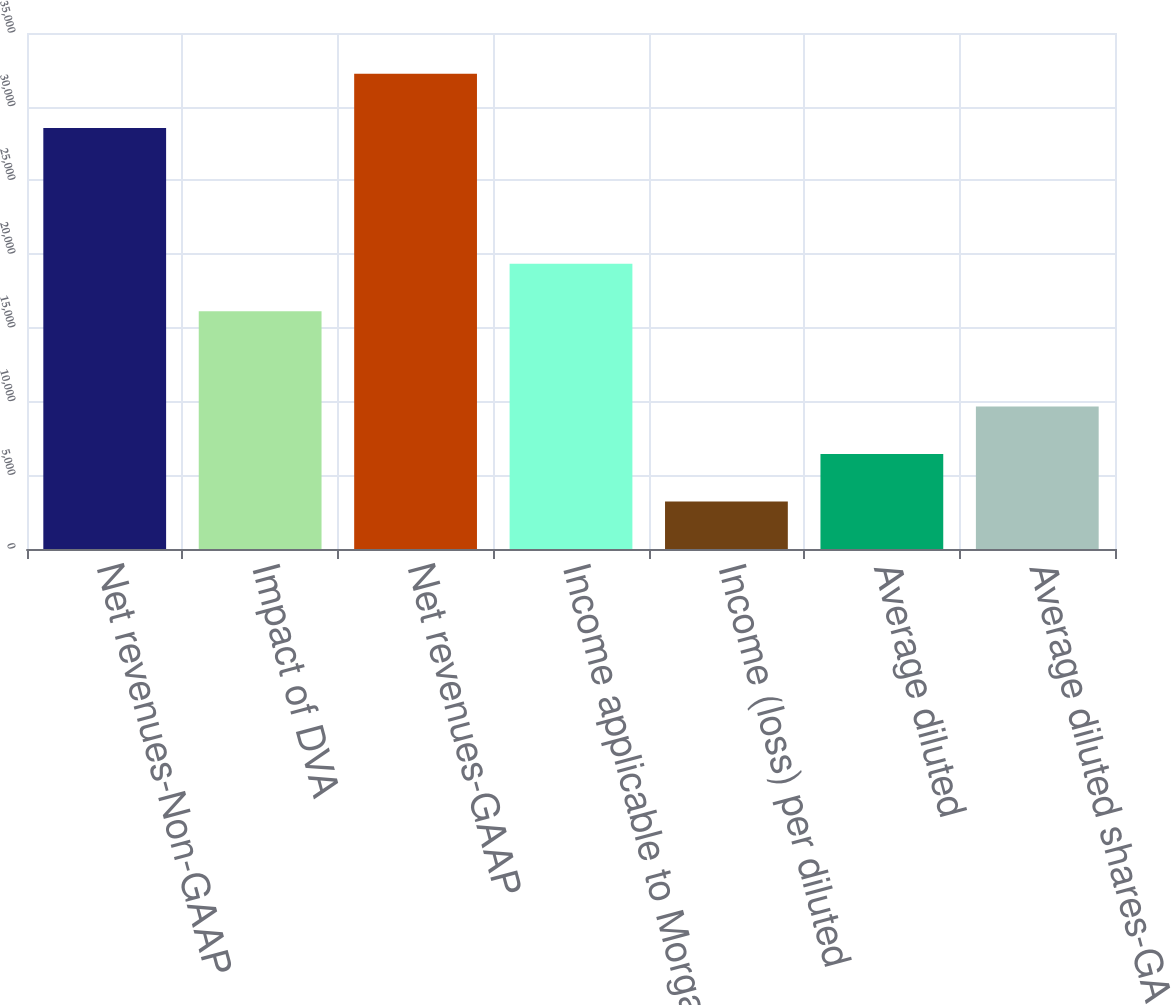Convert chart. <chart><loc_0><loc_0><loc_500><loc_500><bar_chart><fcel>Net revenues-Non-GAAP<fcel>Impact of DVA<fcel>Net revenues-GAAP<fcel>Income applicable to Morgan<fcel>Income (loss) per diluted<fcel>Average diluted<fcel>Average diluted shares-GAAP<nl><fcel>28555<fcel>16118<fcel>32236<fcel>19341.6<fcel>3223.67<fcel>6447.26<fcel>9670.85<nl></chart> 